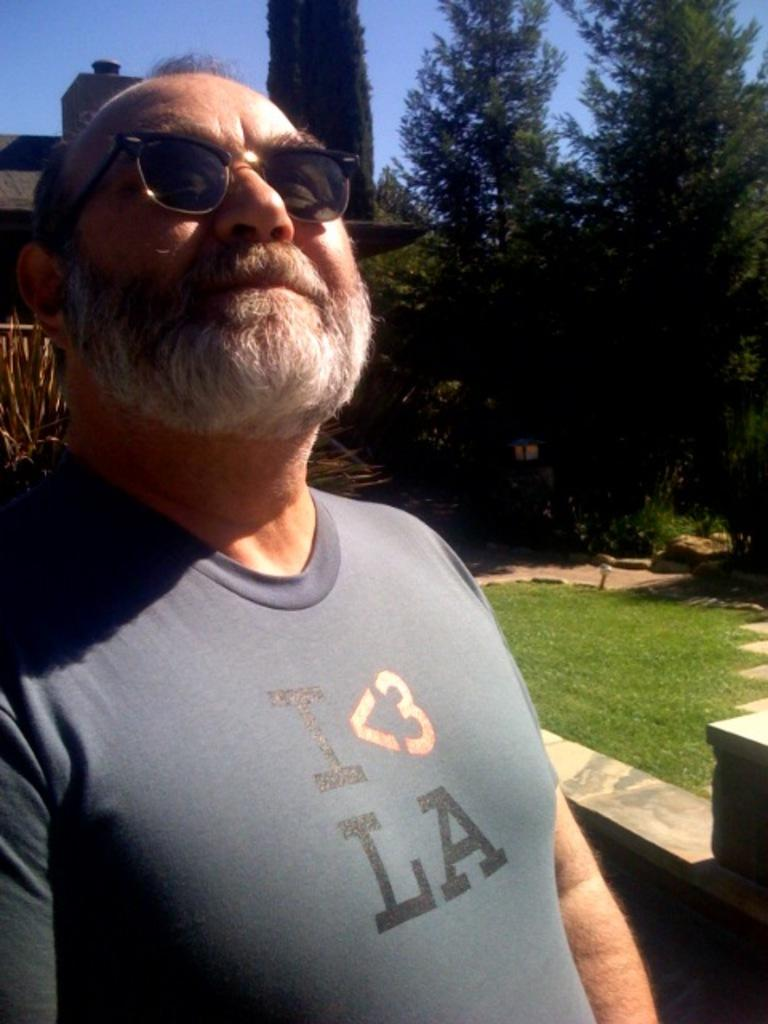What is the person in the image wearing on their face? The person in the image is wearing goggles. What type of surface is visible at the bottom of the image? Grass is present on the surface at the bottom of the image. What can be seen in the background of the image? There are trees and the sky visible in the background of the image. How many dolls are sitting on the grass in the image? There are no dolls present in the image; it features a person wearing goggles and a grassy surface. Who is the friend of the person in the image? There is no friend visible in the image; it only shows a person wearing goggles. 